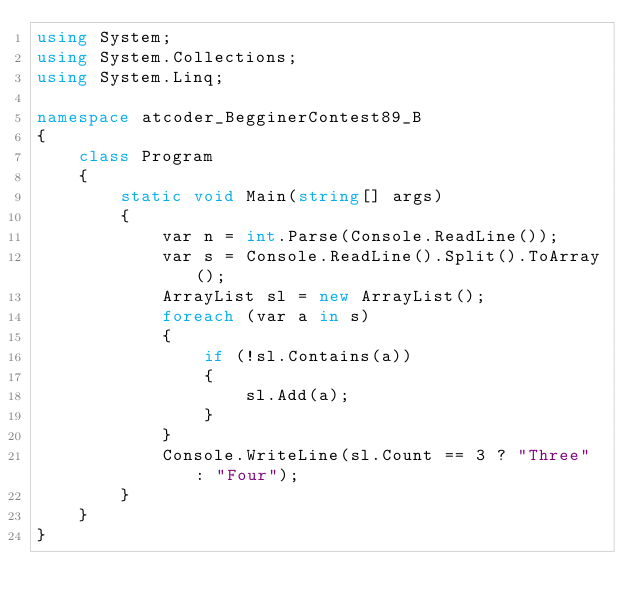Convert code to text. <code><loc_0><loc_0><loc_500><loc_500><_C#_>using System;
using System.Collections;
using System.Linq;

namespace atcoder_BegginerContest89_B
{
    class Program
    {
        static void Main(string[] args)
        {
            var n = int.Parse(Console.ReadLine());
            var s = Console.ReadLine().Split().ToArray();
            ArrayList sl = new ArrayList();
            foreach (var a in s)
            {
                if (!sl.Contains(a))
                {
                    sl.Add(a);
                }
            }
            Console.WriteLine(sl.Count == 3 ? "Three" : "Four");
        }
    }
}
</code> 